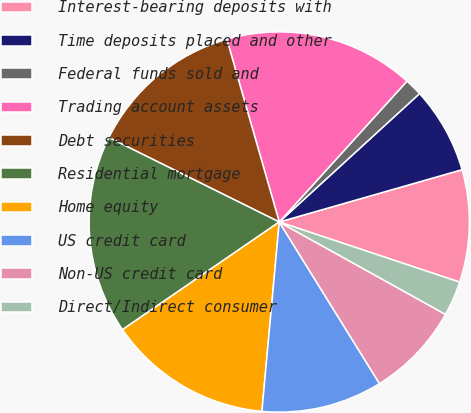<chart> <loc_0><loc_0><loc_500><loc_500><pie_chart><fcel>Interest-bearing deposits with<fcel>Time deposits placed and other<fcel>Federal funds sold and<fcel>Trading account assets<fcel>Debt securities<fcel>Residential mortgage<fcel>Home equity<fcel>US credit card<fcel>Non-US credit card<fcel>Direct/Indirect consumer<nl><fcel>9.56%<fcel>7.36%<fcel>1.48%<fcel>16.17%<fcel>13.23%<fcel>16.9%<fcel>13.97%<fcel>10.29%<fcel>8.09%<fcel>2.95%<nl></chart> 